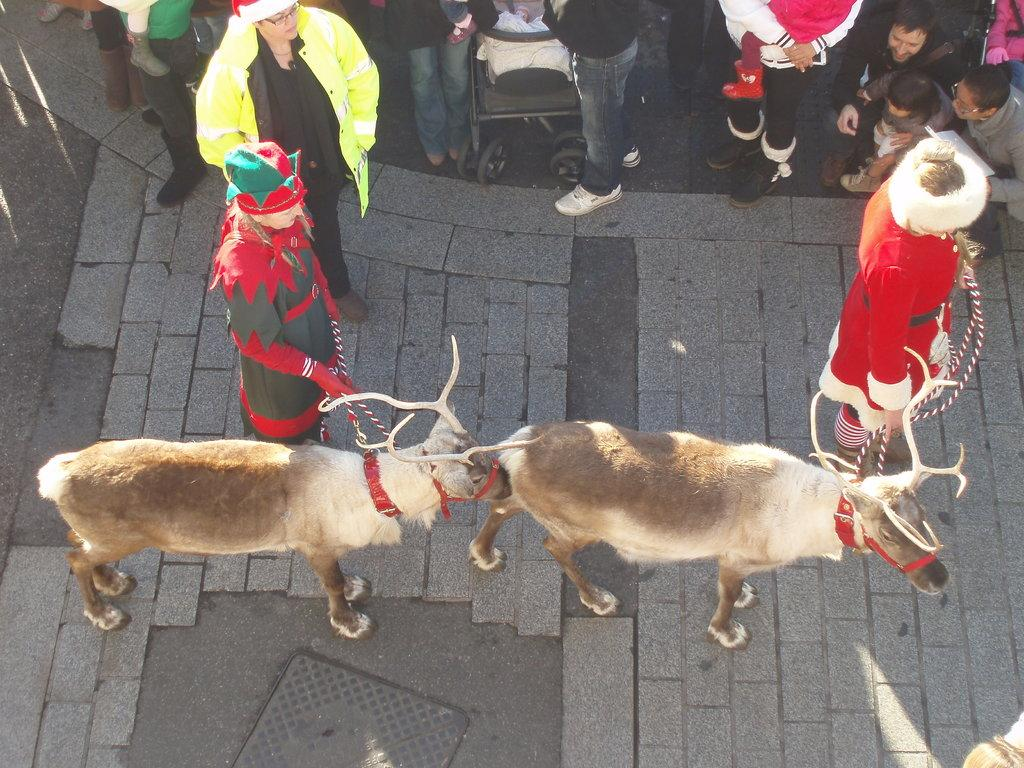How many people are in the image? There are two persons in the image. What are the persons holding in the image? The persons are holding animals. Can you describe the background of the image? There are people in the background of the image, and a stroller is also visible. What type of step can be seen on the stage in the image? There is no stage or step present in the image. What color is the tongue of the animal being held by one of the persons? The image does not show the tongues of the animals, so it cannot be determined from the image. 